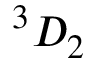<formula> <loc_0><loc_0><loc_500><loc_500>^ { 3 } { D } _ { 2 }</formula> 